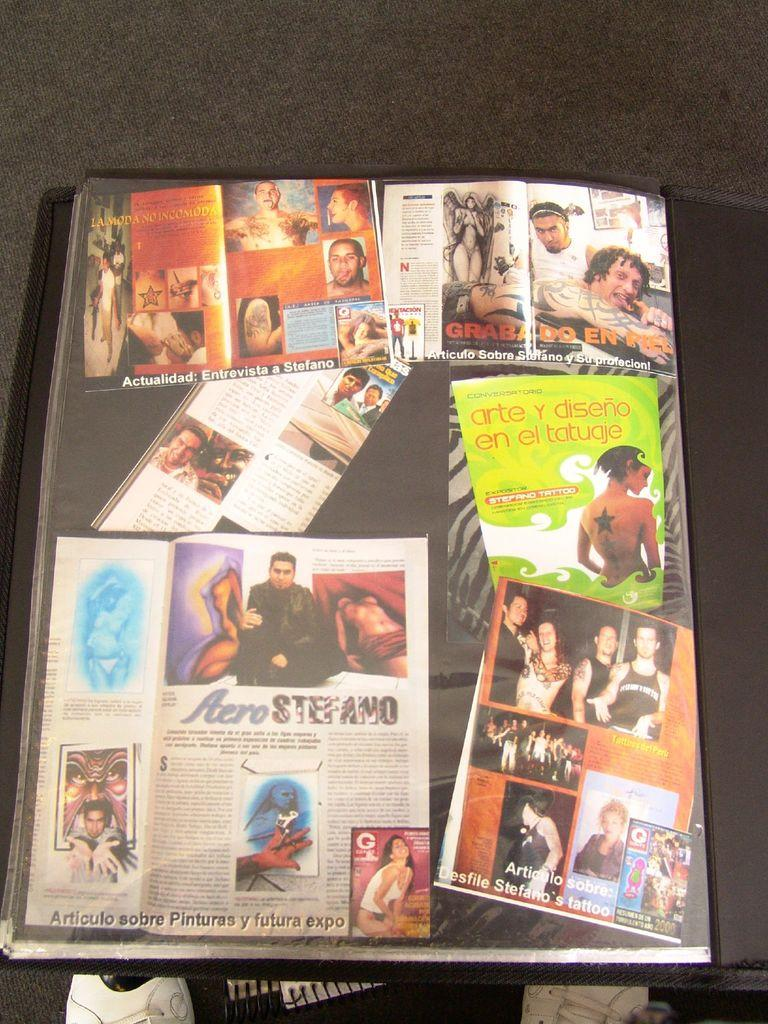<image>
Provide a brief description of the given image. A magazine page with the word Aero visible . 